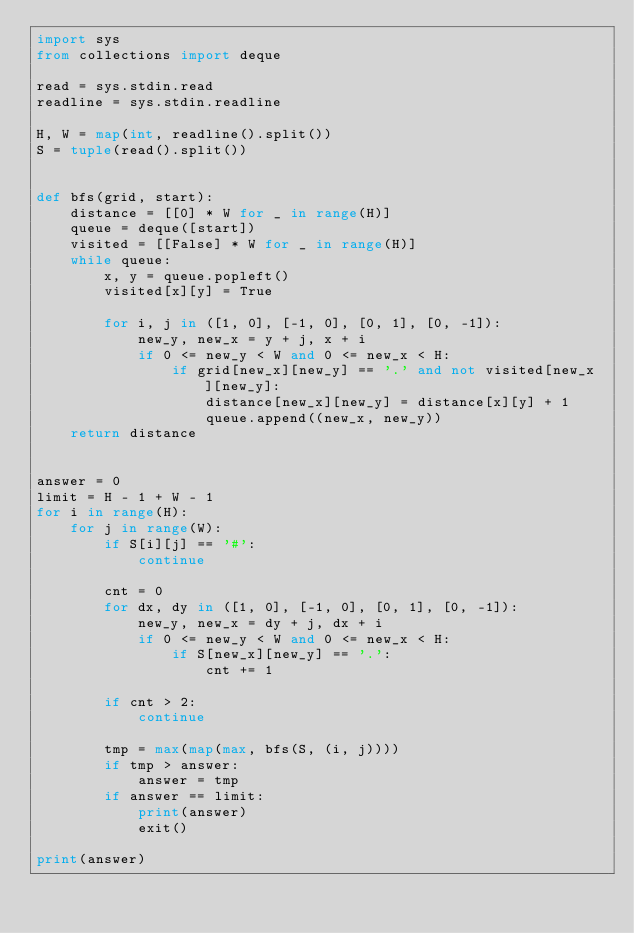<code> <loc_0><loc_0><loc_500><loc_500><_Python_>import sys
from collections import deque

read = sys.stdin.read
readline = sys.stdin.readline

H, W = map(int, readline().split())
S = tuple(read().split())


def bfs(grid, start):
    distance = [[0] * W for _ in range(H)]
    queue = deque([start])
    visited = [[False] * W for _ in range(H)]
    while queue:
        x, y = queue.popleft()
        visited[x][y] = True

        for i, j in ([1, 0], [-1, 0], [0, 1], [0, -1]):
            new_y, new_x = y + j, x + i
            if 0 <= new_y < W and 0 <= new_x < H:
                if grid[new_x][new_y] == '.' and not visited[new_x][new_y]:
                    distance[new_x][new_y] = distance[x][y] + 1
                    queue.append((new_x, new_y))
    return distance


answer = 0
limit = H - 1 + W - 1
for i in range(H):
    for j in range(W):
        if S[i][j] == '#':
            continue

        cnt = 0
        for dx, dy in ([1, 0], [-1, 0], [0, 1], [0, -1]):
            new_y, new_x = dy + j, dx + i
            if 0 <= new_y < W and 0 <= new_x < H:
                if S[new_x][new_y] == '.':
                    cnt += 1

        if cnt > 2:
            continue

        tmp = max(map(max, bfs(S, (i, j))))
        if tmp > answer:
            answer = tmp
        if answer == limit:
            print(answer)
            exit()

print(answer)
</code> 